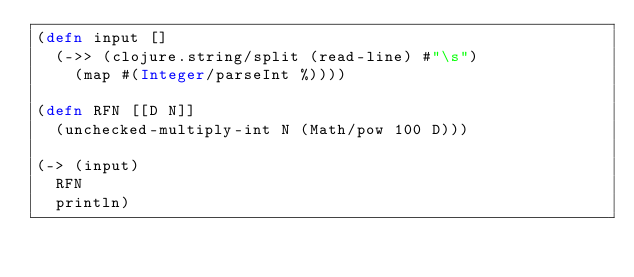<code> <loc_0><loc_0><loc_500><loc_500><_Clojure_>(defn input []
  (->> (clojure.string/split (read-line) #"\s")
    (map #(Integer/parseInt %))))

(defn RFN [[D N]]
  (unchecked-multiply-int N (Math/pow 100 D)))

(-> (input)
  RFN
  println)</code> 